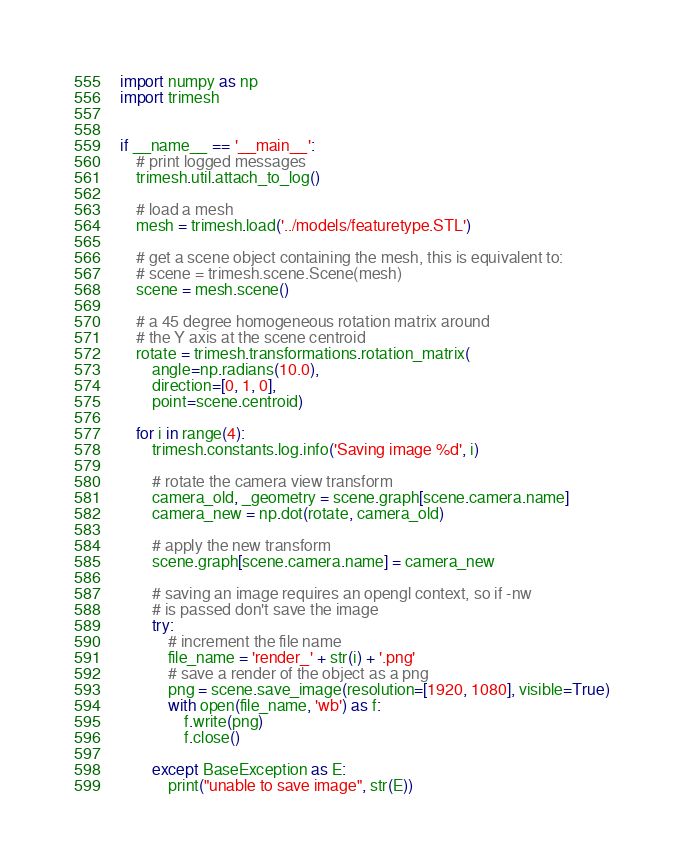Convert code to text. <code><loc_0><loc_0><loc_500><loc_500><_Python_>
import numpy as np
import trimesh


if __name__ == '__main__':
    # print logged messages
    trimesh.util.attach_to_log()

    # load a mesh
    mesh = trimesh.load('../models/featuretype.STL')

    # get a scene object containing the mesh, this is equivalent to:
    # scene = trimesh.scene.Scene(mesh)
    scene = mesh.scene()

    # a 45 degree homogeneous rotation matrix around
    # the Y axis at the scene centroid
    rotate = trimesh.transformations.rotation_matrix(
        angle=np.radians(10.0),
        direction=[0, 1, 0],
        point=scene.centroid)

    for i in range(4):
        trimesh.constants.log.info('Saving image %d', i)

        # rotate the camera view transform
        camera_old, _geometry = scene.graph[scene.camera.name]
        camera_new = np.dot(rotate, camera_old)

        # apply the new transform
        scene.graph[scene.camera.name] = camera_new

        # saving an image requires an opengl context, so if -nw
        # is passed don't save the image
        try:
            # increment the file name
            file_name = 'render_' + str(i) + '.png'
            # save a render of the object as a png
            png = scene.save_image(resolution=[1920, 1080], visible=True)
            with open(file_name, 'wb') as f:
                f.write(png)
                f.close()

        except BaseException as E:
            print("unable to save image", str(E))
</code> 